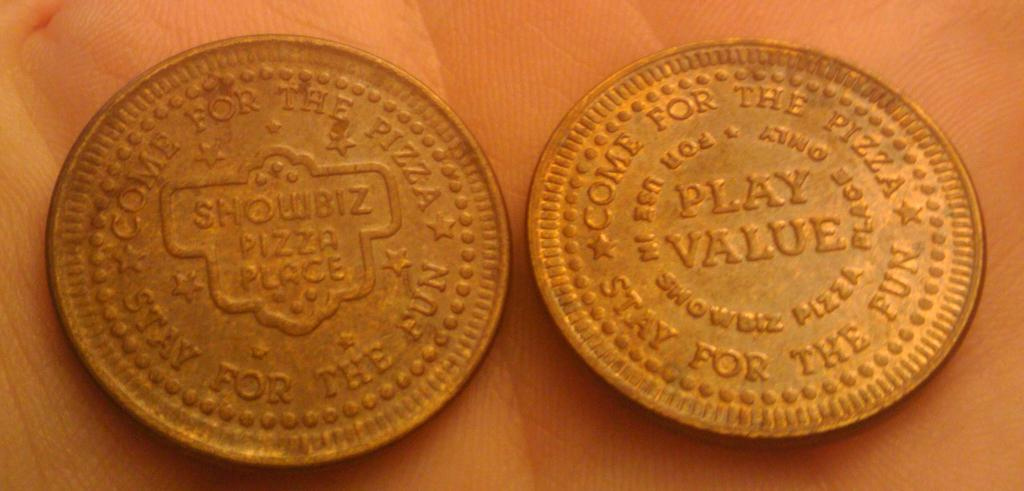<image>
Summarize the visual content of the image. Two tokens from a pizza restaurant are next to each other on a table 